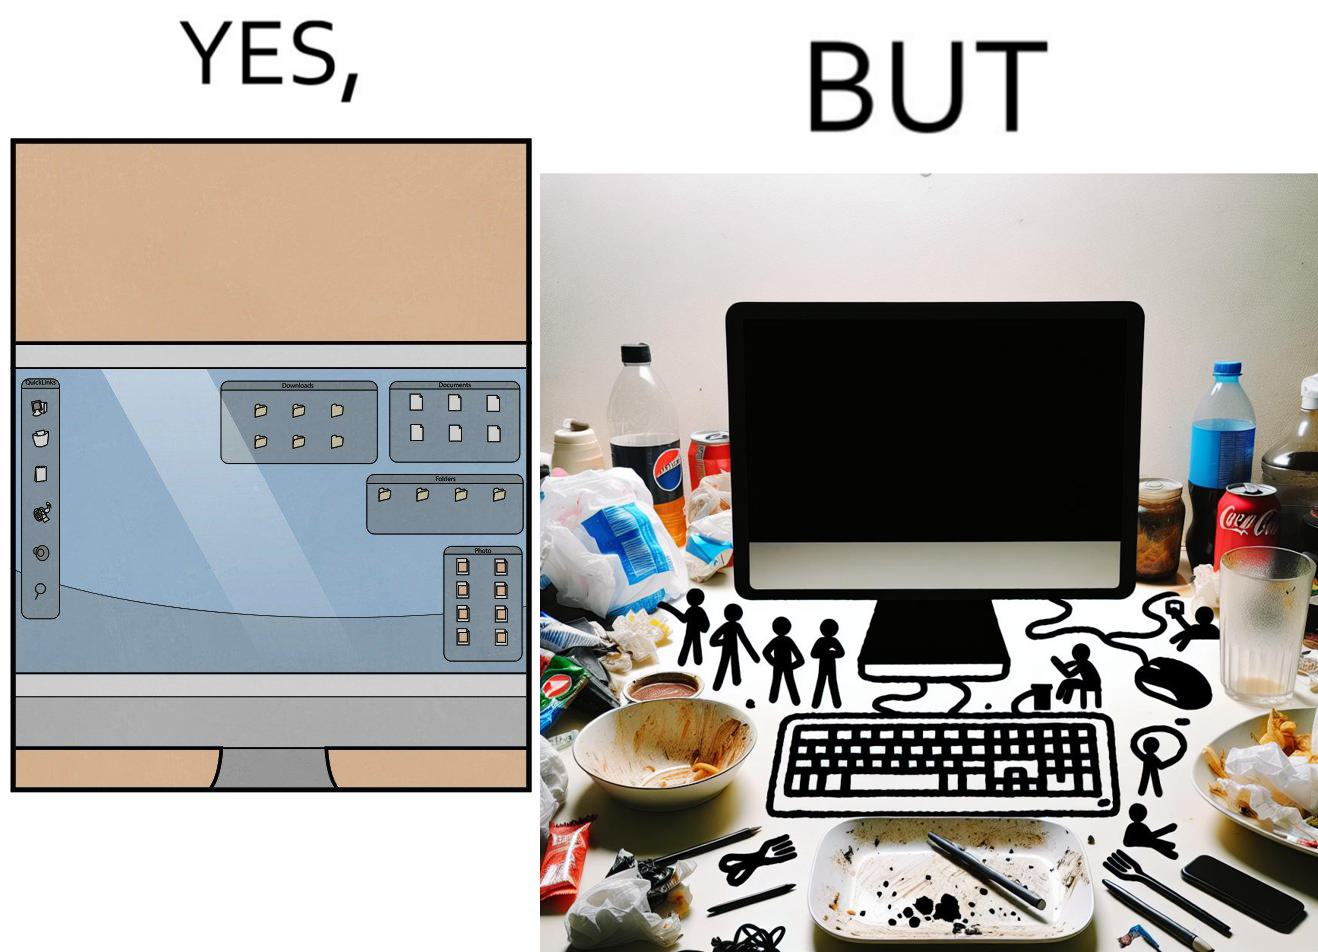What makes this image funny or satirical? The image is ironical, as the folder icons on the desktop screen are very neatly arranged, while the person using the computer has littered the table with used food packets, dirty plates, and wrappers. 